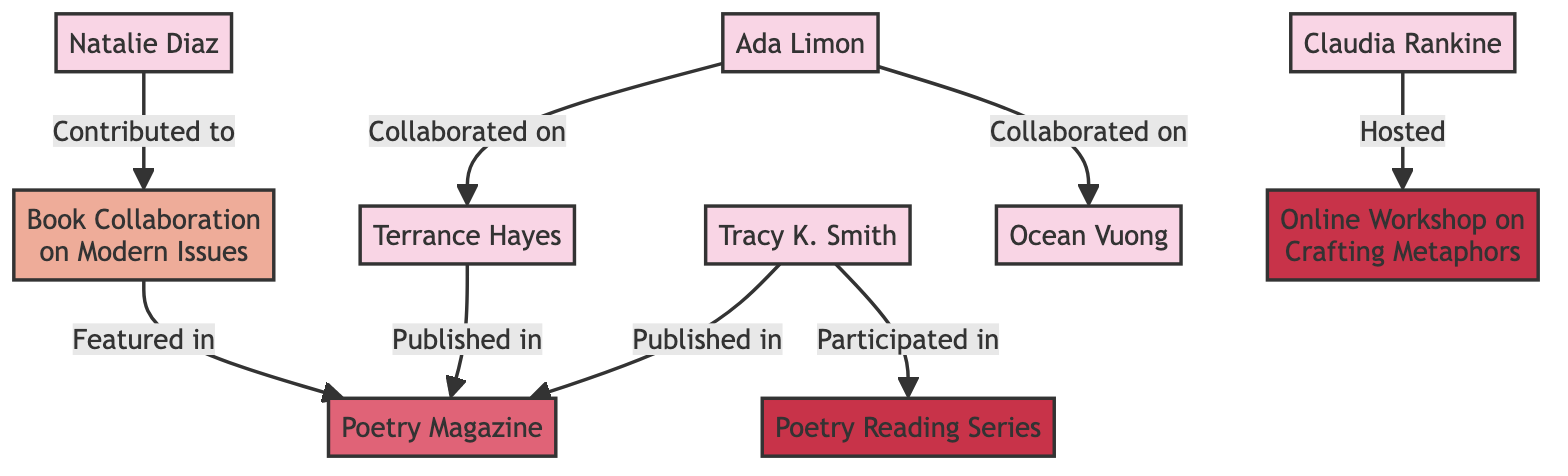What is the total number of poets in the diagram? The diagram lists six poets: Ada Limon, Ocean Vuong, Terrance Hayes, Claudia Rankine, Tracy K. Smith, and Natalie Diaz. By counting these names, we find the total number of poets is six.
Answer: 6 Which poet collaborated with both Ada Limon and Terrance Hayes? By examining the edges, we see that Terrance Hayes is connected to Ada Limon through a collaboration on "Book Collaboration on Modern Issues." However, there is no direct edge indicating that any poet collaborated with both Ada Limon and Terrance Hayes. Thus, the answer is none.
Answer: None How many collaborations are shown in the diagram? The diagram shows three collaborations: Ada Limon with Ocean Vuong, Ada Limon with Terrance Hayes, and Natalie Diaz with the project "Book Collaboration on Modern Issues." Counting these gives us three collaborations.
Answer: 3 What type of relationship connects Claudia Rankine and Ocean Vuong? Analyzing the edges shows that Claudia Rankine has an edge indicating she hosted the "Online Workshop on Crafting Metaphors" linked to Ocean Vuong, and therefore the type of relationship between Claudia Rankine and Ocean Vuong is 'Hosted.'
Answer: Hosted Which project is related to Natalie Diaz? The diagram indicates that Natalie Diaz contributed to the 'Book Collaboration on Modern Issues.' This reflects her involvement with the project as specified in the edges.
Answer: Book Collaboration on Modern Issues How many events are mentioned in the diagram? The diagram displays two events: the "Poetry Reading Series" and the "Online Workshop on Crafting Metaphors." Counting these, we find there are two events mentioned.
Answer: 2 What is the relationship between Terrance Hayes and Poetry Magazine? The edge indicates that Terrance Hayes is 'Published in' the 'Poetry Magazine.' This shows the type of relationship that exists between Terrance Hayes and the publication in the diagram.
Answer: Published in Which poet has the most connections in the diagram? Observing the graph, Ada Limon is connected to Ocean Vuong, Terrance Hayes, and has more relationships through the 'Book Collaboration on Modern Issues' and also to the 'Online Workshop on Crafting Metaphors.' After counting all edges connected to each poet, Ada Limon has the most connections.
Answer: Ada Limon 